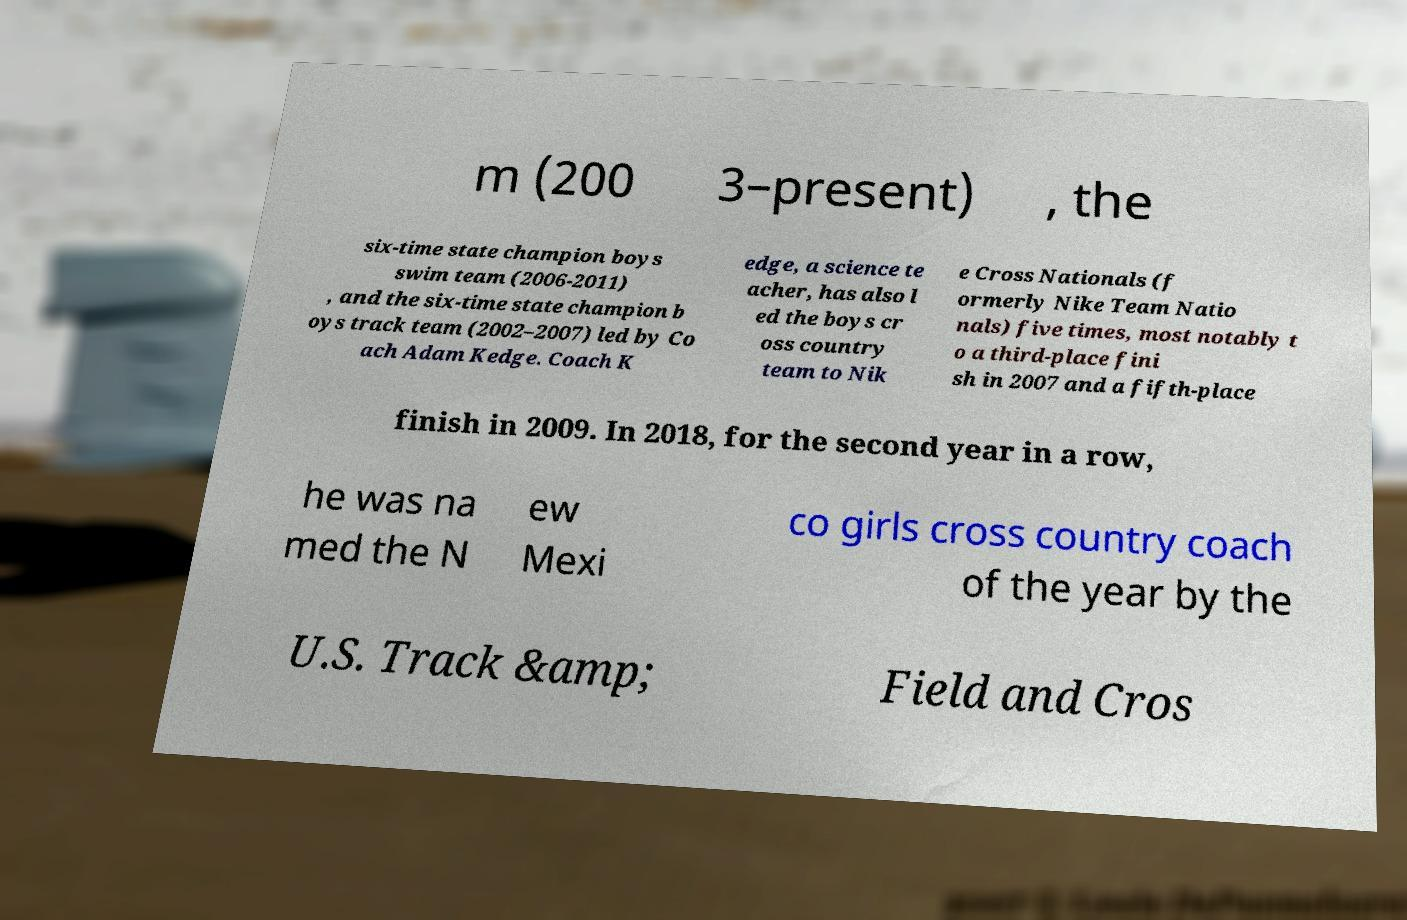Could you assist in decoding the text presented in this image and type it out clearly? m (200 3–present) , the six-time state champion boys swim team (2006-2011) , and the six-time state champion b oys track team (2002–2007) led by Co ach Adam Kedge. Coach K edge, a science te acher, has also l ed the boys cr oss country team to Nik e Cross Nationals (f ormerly Nike Team Natio nals) five times, most notably t o a third-place fini sh in 2007 and a fifth-place finish in 2009. In 2018, for the second year in a row, he was na med the N ew Mexi co girls cross country coach of the year by the U.S. Track &amp; Field and Cros 